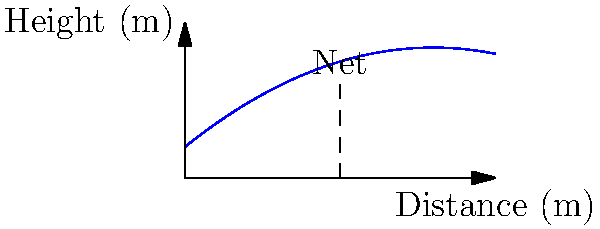As a former professional tennis player, you're coaching a young talent. You serve a tennis ball with an initial velocity of 160 km/h at an angle of 15 degrees above the horizontal. The polynomial function representing the trajectory of the ball is given by $h(x) = -0.05x^2 + 0.8x + 1$, where $h$ is the height in meters and $x$ is the horizontal distance in meters. What is the maximum height reached by the ball during its trajectory? To find the maximum height of the ball's trajectory, we need to follow these steps:

1) The trajectory is represented by a quadratic function $h(x) = -0.05x^2 + 0.8x + 1$

2) The maximum point of a parabola occurs at the vertex. For a quadratic function in the form $ax^2 + bx + c$, the x-coordinate of the vertex is given by $x = -\frac{b}{2a}$

3) In our case, $a = -0.05$ and $b = 0.8$

4) Let's calculate the x-coordinate of the vertex:
   $x = -\frac{0.8}{2(-0.05)} = -\frac{0.8}{-0.1} = 8$ meters

5) To find the maximum height, we need to substitute this x-value back into our original function:

   $h(8) = -0.05(8)^2 + 0.8(8) + 1$
         $= -0.05(64) + 6.4 + 1$
         $= -3.2 + 6.4 + 1$
         $= 4.2$ meters

Therefore, the maximum height reached by the ball is 4.2 meters.
Answer: 4.2 meters 